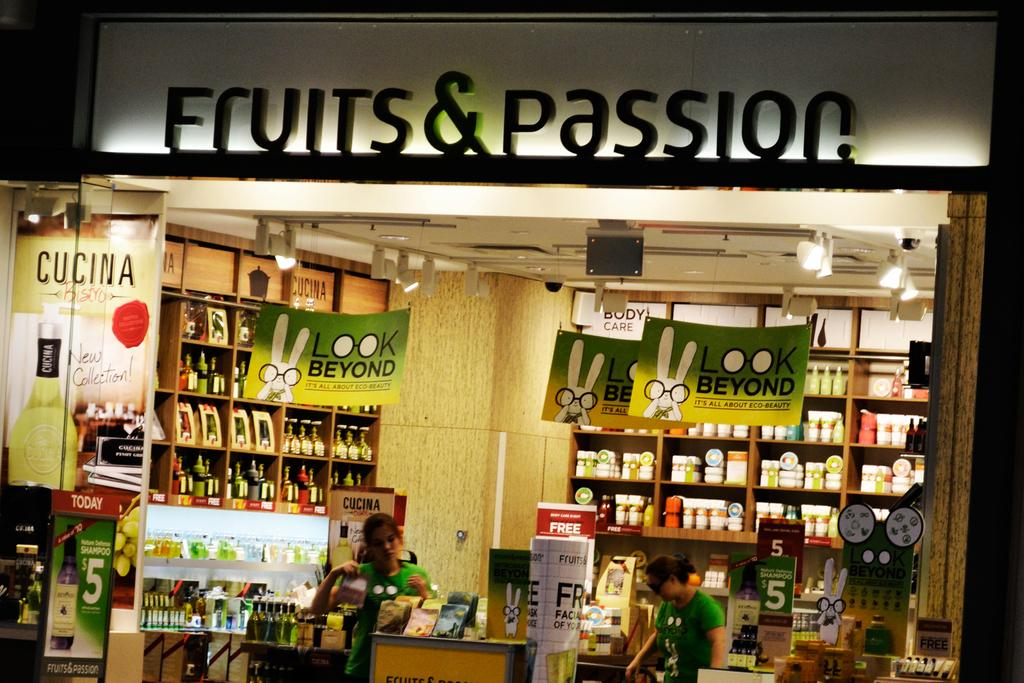<image>
Describe the image concisely. The front entrance of a store called Fruits and Passion. 